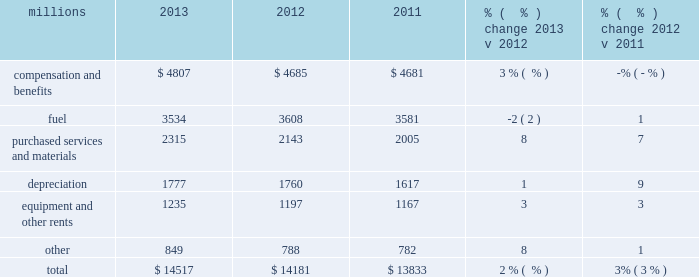Operating expenses millions 2013 2012 2011 % (  % ) change 2013 v 2012 % (  % ) change 2012 v 2011 .
Operating expenses increased $ 336 million in 2013 versus 2012 .
Wage and benefit inflation , new logistics management fees and container costs for our automotive business , locomotive overhauls , property taxes and repairs on jointly owned property contributed to higher expenses during the year .
Lower fuel prices partially offset the cost increases .
Operating expenses increased $ 348 million in 2012 versus 2011 .
Depreciation , wage and benefit inflation , higher fuel prices and volume- related trucking services purchased by our logistics subsidiaries , contributed to higher expenses during the year .
Efficiency gains , volume related fuel savings ( 2% ( 2 % ) fewer gallons of fuel consumed ) and $ 38 million of weather related expenses in 2011 , which favorably affects the comparison , partially offset the cost increase .
Compensation and benefits 2013 compensation and benefits include wages , payroll taxes , health and welfare costs , pension costs , other postretirement benefits , and incentive costs .
General wages and benefits inflation , higher work force levels and increased pension and other postretirement benefits drove the increases in 2013 versus 2012 .
The impact of ongoing productivity initiatives partially offset these increases .
Expenses in 2012 were essentially flat versus 2011 as operational improvements and cost reductions offset general wage and benefit inflation and higher pension and other postretirement benefits .
In addition , weather related costs increased these expenses in 2011 .
Fuel 2013 fuel includes locomotive fuel and gasoline for highway and non-highway vehicles and heavy equipment .
Lower locomotive diesel fuel prices , which averaged $ 3.15 per gallon ( including taxes and transportation costs ) in 2013 , compared to $ 3.22 in 2012 , decreased expenses by $ 75 million .
Volume , as measured by gross ton-miles , decreased 1% ( 1 % ) while the fuel consumption rate , computed as gallons of fuel consumed divided by gross ton-miles , increased 2% ( 2 % ) compared to 2012 .
Declines in heavier , more fuel-efficient coal shipments drove the variances in gross-ton-miles and the fuel consumption rate .
Higher locomotive diesel fuel prices , which averaged $ 3.22 per gallon ( including taxes and transportation costs ) in 2012 , compared to $ 3.12 in 2011 , increased expenses by $ 105 million .
Volume , as measured by gross ton-miles , decreased 2% ( 2 % ) in 2012 versus 2011 , driving expense down .
The fuel consumption rate was flat year-over-year .
Purchased services and materials 2013 expense for purchased services and materials includes the costs of services purchased from outside contractors and other service providers ( including equipment maintenance and contract expenses incurred by our subsidiaries for external transportation services ) ; materials used to maintain the railroad 2019s lines , structures , and equipment ; costs of operating facilities jointly used by uprr and other railroads ; transportation and lodging for train crew employees ; trucking and contracting costs for intermodal containers ; leased automobile maintenance expenses ; and tools and 2013 operating expenses .
In 2012 what was the percent of the total operating expenses for the compensation and benefits? 
Computations: (4685 / 14181)
Answer: 0.33037. 